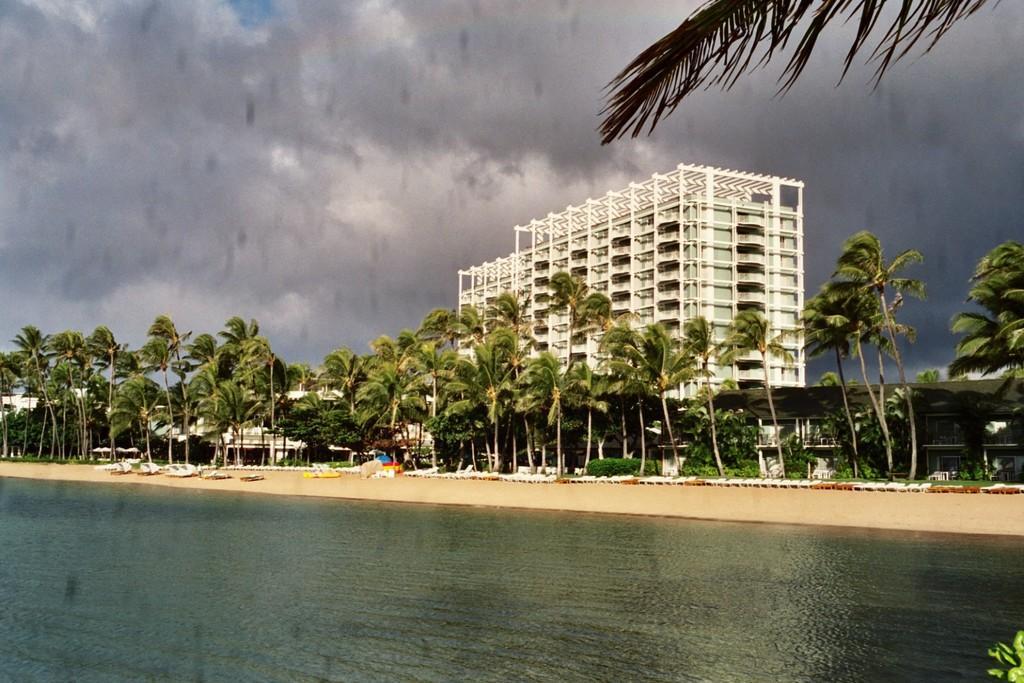Please provide a concise description of this image. This is an outside view. Here I can see beach. At the bottom of the image I can see the water. In the background there are many trees and buildings. At the top I can see in the sky and it is cloudy. 